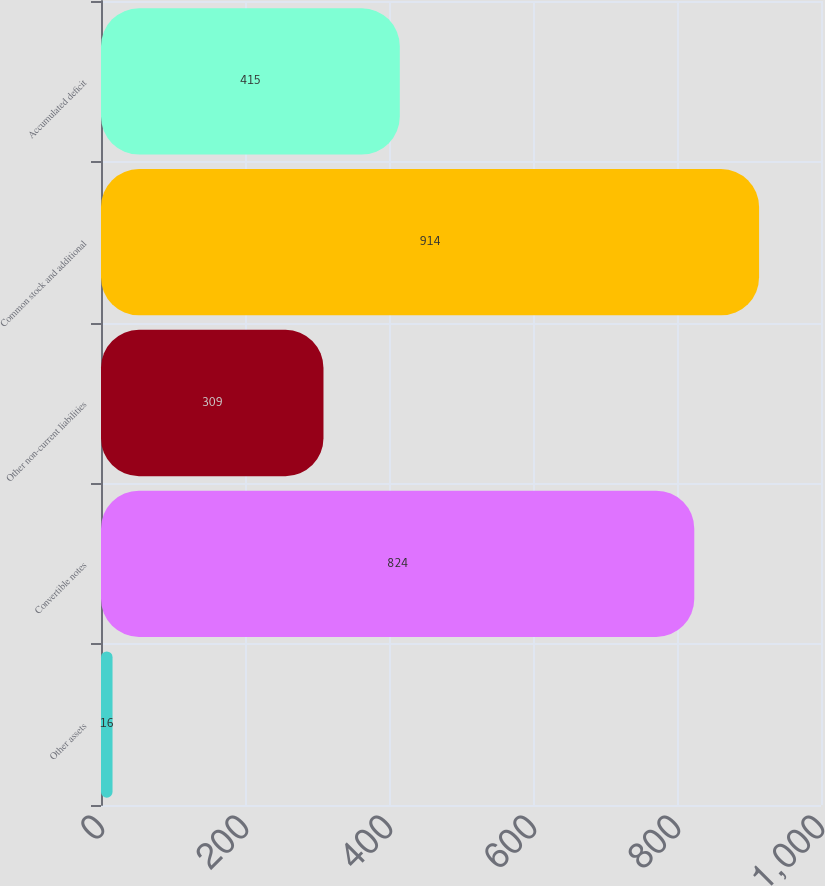Convert chart to OTSL. <chart><loc_0><loc_0><loc_500><loc_500><bar_chart><fcel>Other assets<fcel>Convertible notes<fcel>Other non-current liabilities<fcel>Common stock and additional<fcel>Accumulated deficit<nl><fcel>16<fcel>824<fcel>309<fcel>914<fcel>415<nl></chart> 